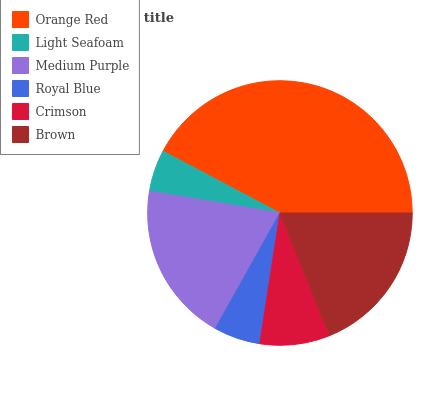Is Light Seafoam the minimum?
Answer yes or no. Yes. Is Orange Red the maximum?
Answer yes or no. Yes. Is Medium Purple the minimum?
Answer yes or no. No. Is Medium Purple the maximum?
Answer yes or no. No. Is Medium Purple greater than Light Seafoam?
Answer yes or no. Yes. Is Light Seafoam less than Medium Purple?
Answer yes or no. Yes. Is Light Seafoam greater than Medium Purple?
Answer yes or no. No. Is Medium Purple less than Light Seafoam?
Answer yes or no. No. Is Brown the high median?
Answer yes or no. Yes. Is Crimson the low median?
Answer yes or no. Yes. Is Medium Purple the high median?
Answer yes or no. No. Is Medium Purple the low median?
Answer yes or no. No. 